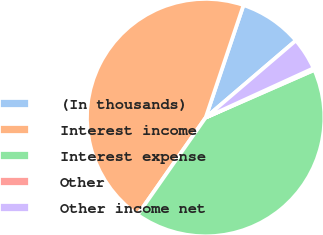Convert chart to OTSL. <chart><loc_0><loc_0><loc_500><loc_500><pie_chart><fcel>(In thousands)<fcel>Interest income<fcel>Interest expense<fcel>Other<fcel>Other income net<nl><fcel>8.58%<fcel>45.45%<fcel>41.29%<fcel>0.26%<fcel>4.42%<nl></chart> 